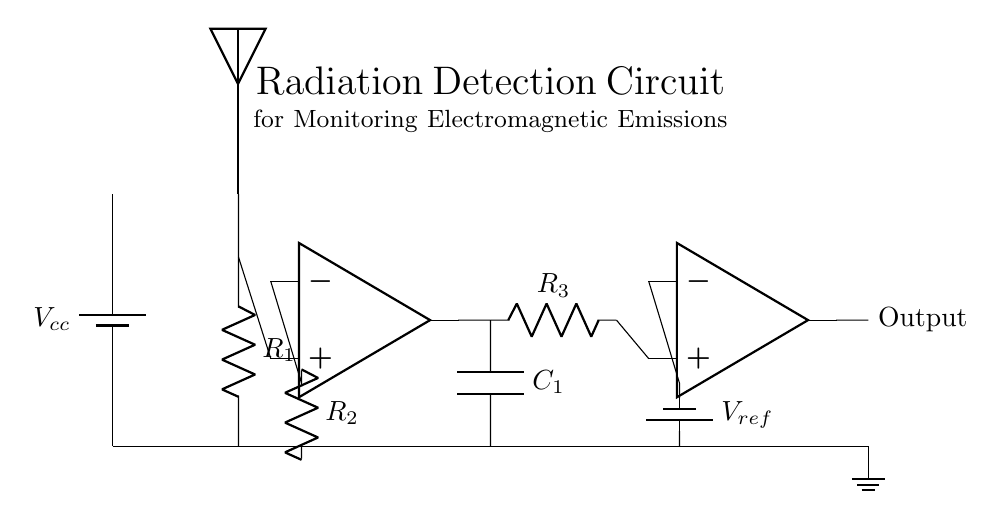What type of sensor is used in this circuit? The circuit diagram shows an antenna symbol, indicating that a radiation sensor, specifically an antenna, is used to detect electromagnetic emissions.
Answer: Antenna What is the role of the amplifier in this circuit? The amplifier, represented by the operational amplifier symbol in the diagram, boosts the signal strength from the radiation sensor, helping to improve the detection of the emitted radiation.
Answer: Signal boosting How many resistors are in the circuit? The circuit contains three resistors indicated by their labels (R1, R2, and R3), making them clearly identifiable components that influence the circuit's behavior.
Answer: Three What is the reference voltage used in the comparator? The circuit shows a voltage source labeled V_ref connected to the inverting terminal of the comparator. The value of this voltage is not specified numerically, but it is critical for the comparator's operation in this context.
Answer: V_ref What is the function of the capacitor in this circuit? The capacitor (C1) in the circuit acts as a filter, smoothing out variations in the signal and ensuring that only specific frequencies pass through to the output, which is essential for clean signal processing.
Answer: Filtering What happens at the output of the comparator? The output of the comparator outputs a logical signal based on the comparison between the amplified sensor signal and the reference voltage, determining whether the detected emissions exceed safety limits.
Answer: Logical signal How is the ground reference established in the circuit? The ground reference is established by a direct connection to the ground symbol in the circuit, providing a common return path for current and a reference point for all voltage levels within the circuit.
Answer: Ground connection 